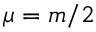Convert formula to latex. <formula><loc_0><loc_0><loc_500><loc_500>\mu = m / 2</formula> 